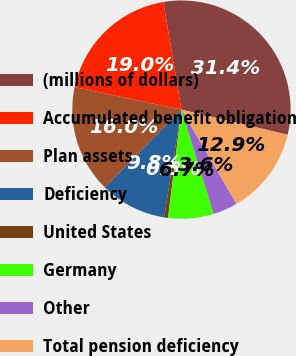<chart> <loc_0><loc_0><loc_500><loc_500><pie_chart><fcel>(millions of dollars)<fcel>Accumulated benefit obligation<fcel>Plan assets<fcel>Deficiency<fcel>United States<fcel>Germany<fcel>Other<fcel>Total pension deficiency<nl><fcel>31.35%<fcel>19.04%<fcel>15.96%<fcel>9.81%<fcel>0.58%<fcel>6.73%<fcel>3.65%<fcel>12.88%<nl></chart> 